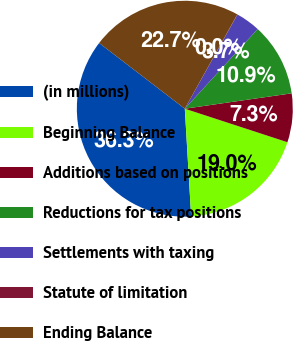Convert chart. <chart><loc_0><loc_0><loc_500><loc_500><pie_chart><fcel>(in millions)<fcel>Beginning Balance<fcel>Additions based on positions<fcel>Reductions for tax positions<fcel>Settlements with taxing<fcel>Statute of limitation<fcel>Ending Balance<nl><fcel>36.35%<fcel>19.04%<fcel>7.3%<fcel>10.93%<fcel>3.67%<fcel>0.04%<fcel>22.67%<nl></chart> 